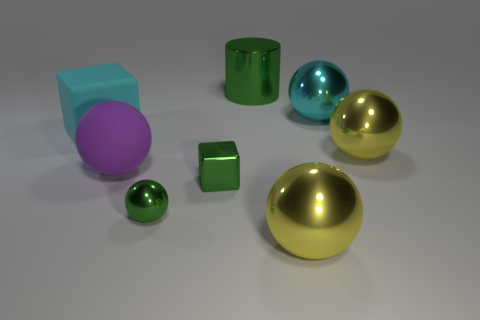Subtract all cyan balls. How many balls are left? 4 Subtract all tiny green balls. How many balls are left? 4 Subtract all blue spheres. Subtract all red cubes. How many spheres are left? 5 Add 1 tiny gray metal cubes. How many objects exist? 9 Subtract all cylinders. How many objects are left? 7 Subtract all tiny green metal balls. Subtract all tiny metal objects. How many objects are left? 5 Add 1 big matte cubes. How many big matte cubes are left? 2 Add 2 metallic balls. How many metallic balls exist? 6 Subtract 1 purple spheres. How many objects are left? 7 